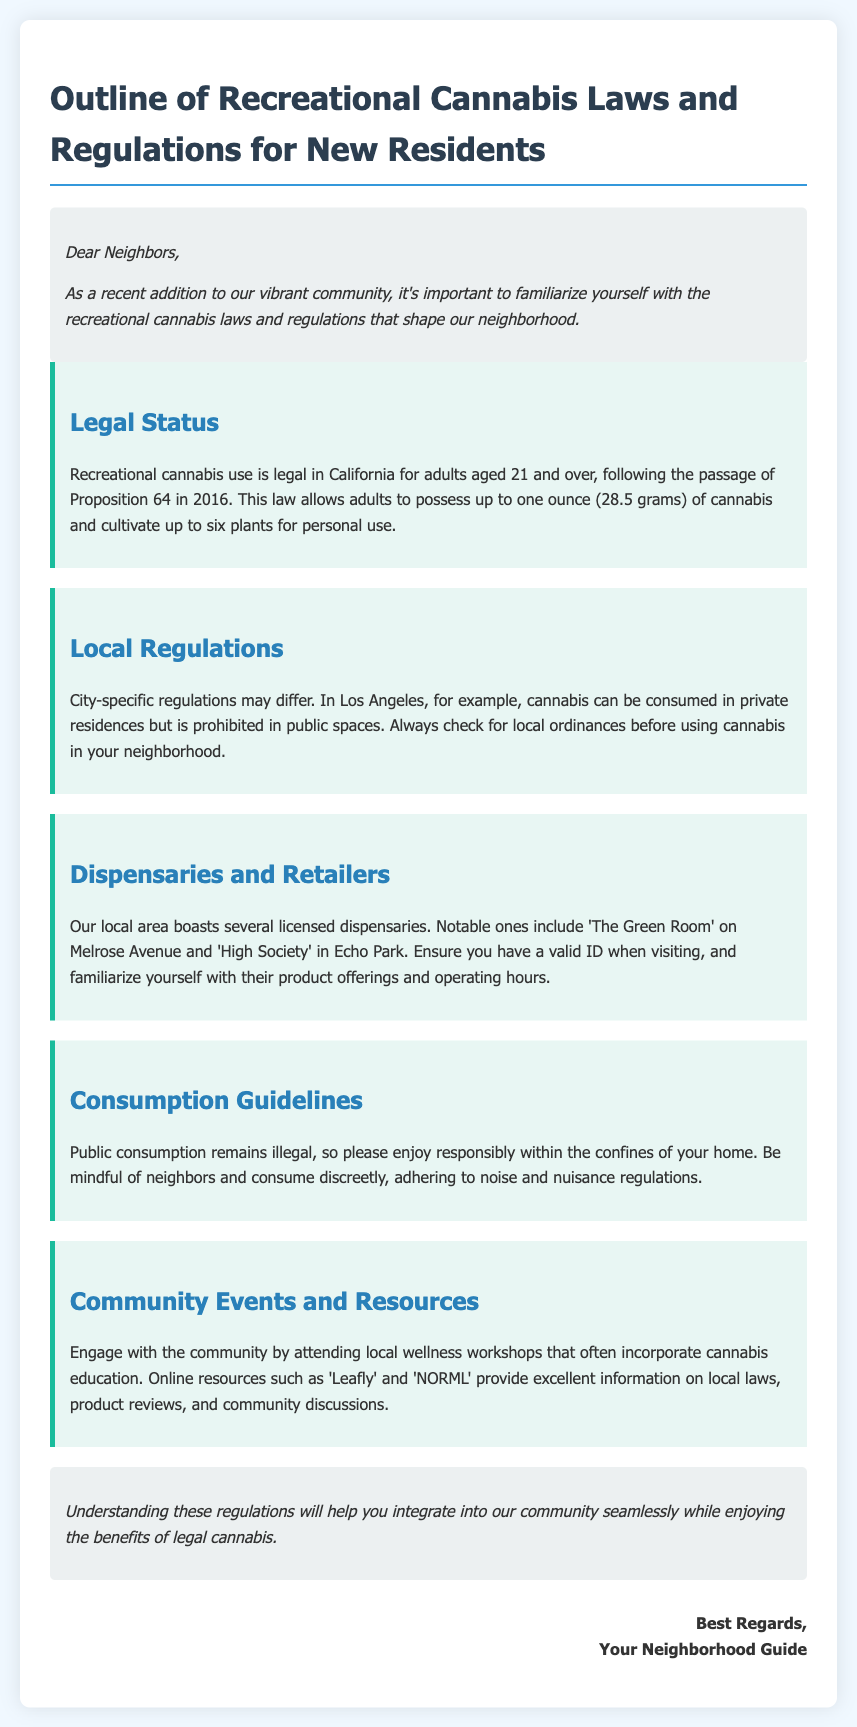What is the legal age for recreational cannabis use? The legal age for recreational cannabis use is specified in the document as 21 years and over.
Answer: 21 How many plants can an adult cultivate for personal use? The memo states that adults can cultivate up to six plants for personal use.
Answer: Six What are the names of two local dispensaries mentioned in the document? The document provides the names of notable dispensaries in the area, which are 'The Green Room' and 'High Society'.
Answer: The Green Room, High Society Is public consumption of cannabis legal in the area? The laws outlined in the document indicate that public consumption of cannabis is illegal, requiring consumption to take place in private residences.
Answer: No What is the main purpose of the memo? The memo's purpose is to inform new residents about recreational cannabis laws and regulations that affect the community.
Answer: Inform Which organization provides information on local laws and product reviews? The document mentions 'Leafly' as an online resource providing information on local laws and product reviews.
Answer: Leafly 